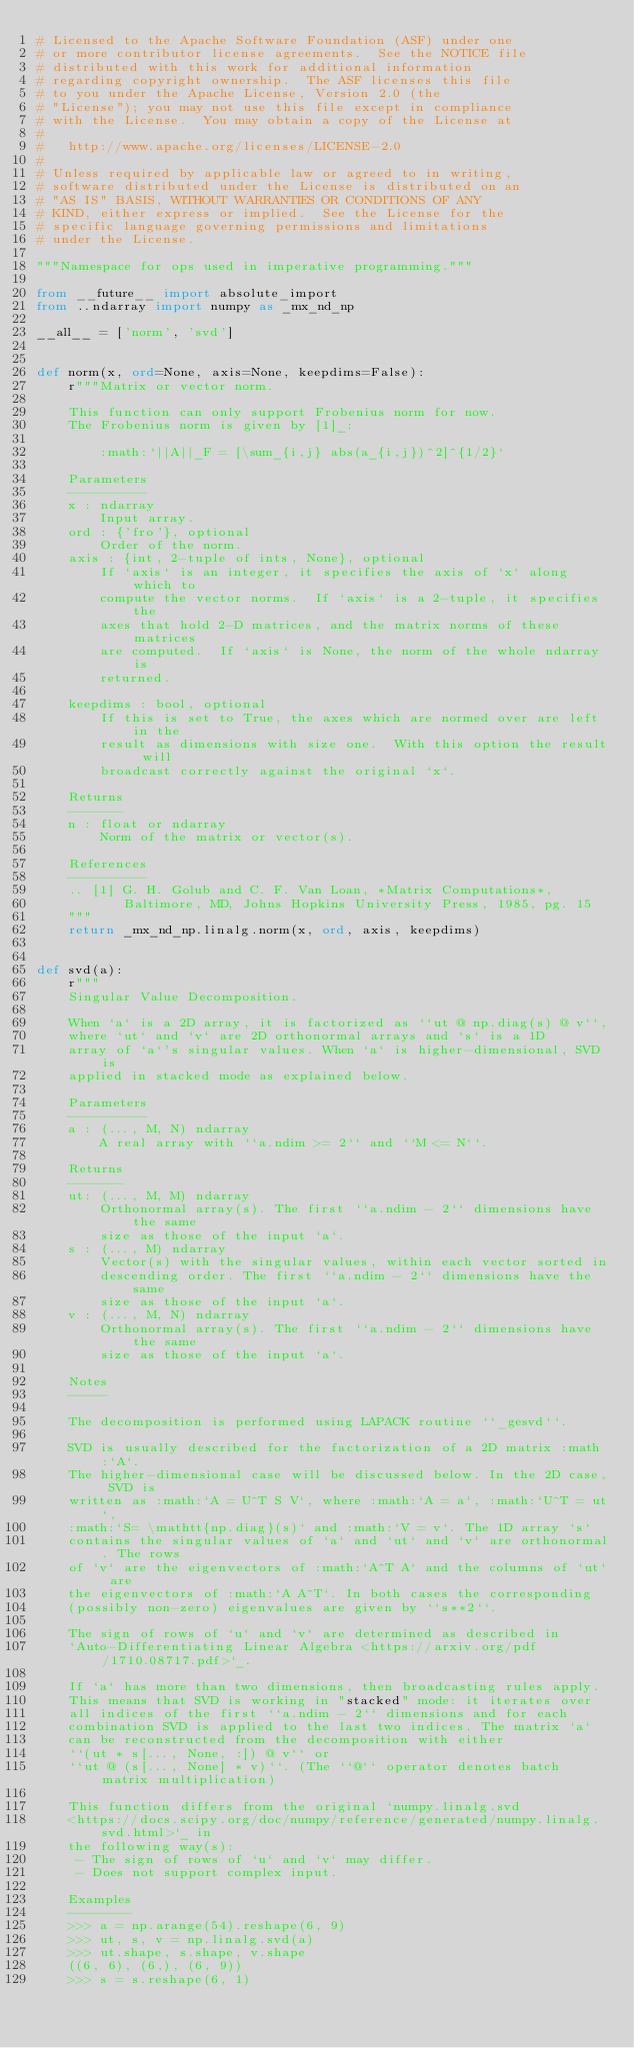Convert code to text. <code><loc_0><loc_0><loc_500><loc_500><_Python_># Licensed to the Apache Software Foundation (ASF) under one
# or more contributor license agreements.  See the NOTICE file
# distributed with this work for additional information
# regarding copyright ownership.  The ASF licenses this file
# to you under the Apache License, Version 2.0 (the
# "License"); you may not use this file except in compliance
# with the License.  You may obtain a copy of the License at
#
#   http://www.apache.org/licenses/LICENSE-2.0
#
# Unless required by applicable law or agreed to in writing,
# software distributed under the License is distributed on an
# "AS IS" BASIS, WITHOUT WARRANTIES OR CONDITIONS OF ANY
# KIND, either express or implied.  See the License for the
# specific language governing permissions and limitations
# under the License.

"""Namespace for ops used in imperative programming."""

from __future__ import absolute_import
from ..ndarray import numpy as _mx_nd_np

__all__ = ['norm', 'svd']


def norm(x, ord=None, axis=None, keepdims=False):
    r"""Matrix or vector norm.

    This function can only support Frobenius norm for now.
    The Frobenius norm is given by [1]_:

        :math:`||A||_F = [\sum_{i,j} abs(a_{i,j})^2]^{1/2}`

    Parameters
    ----------
    x : ndarray
        Input array.
    ord : {'fro'}, optional
        Order of the norm.
    axis : {int, 2-tuple of ints, None}, optional
        If `axis` is an integer, it specifies the axis of `x` along which to
        compute the vector norms.  If `axis` is a 2-tuple, it specifies the
        axes that hold 2-D matrices, and the matrix norms of these matrices
        are computed.  If `axis` is None, the norm of the whole ndarray is
        returned.

    keepdims : bool, optional
        If this is set to True, the axes which are normed over are left in the
        result as dimensions with size one.  With this option the result will
        broadcast correctly against the original `x`.

    Returns
    -------
    n : float or ndarray
        Norm of the matrix or vector(s).

    References
    ----------
    .. [1] G. H. Golub and C. F. Van Loan, *Matrix Computations*,
           Baltimore, MD, Johns Hopkins University Press, 1985, pg. 15
    """
    return _mx_nd_np.linalg.norm(x, ord, axis, keepdims)


def svd(a):
    r"""
    Singular Value Decomposition.

    When `a` is a 2D array, it is factorized as ``ut @ np.diag(s) @ v``,
    where `ut` and `v` are 2D orthonormal arrays and `s` is a 1D
    array of `a`'s singular values. When `a` is higher-dimensional, SVD is
    applied in stacked mode as explained below.

    Parameters
    ----------
    a : (..., M, N) ndarray
        A real array with ``a.ndim >= 2`` and ``M <= N``.

    Returns
    -------
    ut: (..., M, M) ndarray
        Orthonormal array(s). The first ``a.ndim - 2`` dimensions have the same
        size as those of the input `a`.
    s : (..., M) ndarray
        Vector(s) with the singular values, within each vector sorted in
        descending order. The first ``a.ndim - 2`` dimensions have the same
        size as those of the input `a`.
    v : (..., M, N) ndarray
        Orthonormal array(s). The first ``a.ndim - 2`` dimensions have the same
        size as those of the input `a`.

    Notes
    -----

    The decomposition is performed using LAPACK routine ``_gesvd``.

    SVD is usually described for the factorization of a 2D matrix :math:`A`.
    The higher-dimensional case will be discussed below. In the 2D case, SVD is
    written as :math:`A = U^T S V`, where :math:`A = a`, :math:`U^T = ut`,
    :math:`S= \mathtt{np.diag}(s)` and :math:`V = v`. The 1D array `s`
    contains the singular values of `a` and `ut` and `v` are orthonormal. The rows
    of `v` are the eigenvectors of :math:`A^T A` and the columns of `ut` are
    the eigenvectors of :math:`A A^T`. In both cases the corresponding
    (possibly non-zero) eigenvalues are given by ``s**2``.

    The sign of rows of `u` and `v` are determined as described in
    `Auto-Differentiating Linear Algebra <https://arxiv.org/pdf/1710.08717.pdf>`_.

    If `a` has more than two dimensions, then broadcasting rules apply.
    This means that SVD is working in "stacked" mode: it iterates over
    all indices of the first ``a.ndim - 2`` dimensions and for each
    combination SVD is applied to the last two indices. The matrix `a`
    can be reconstructed from the decomposition with either
    ``(ut * s[..., None, :]) @ v`` or
    ``ut @ (s[..., None] * v)``. (The ``@`` operator denotes batch matrix multiplication)

    This function differs from the original `numpy.linalg.svd
    <https://docs.scipy.org/doc/numpy/reference/generated/numpy.linalg.svd.html>`_ in
    the following way(s):
     - The sign of rows of `u` and `v` may differ.
     - Does not support complex input.

    Examples
    --------
    >>> a = np.arange(54).reshape(6, 9)
    >>> ut, s, v = np.linalg.svd(a)
    >>> ut.shape, s.shape, v.shape
    ((6, 6), (6,), (6, 9))
    >>> s = s.reshape(6, 1)</code> 